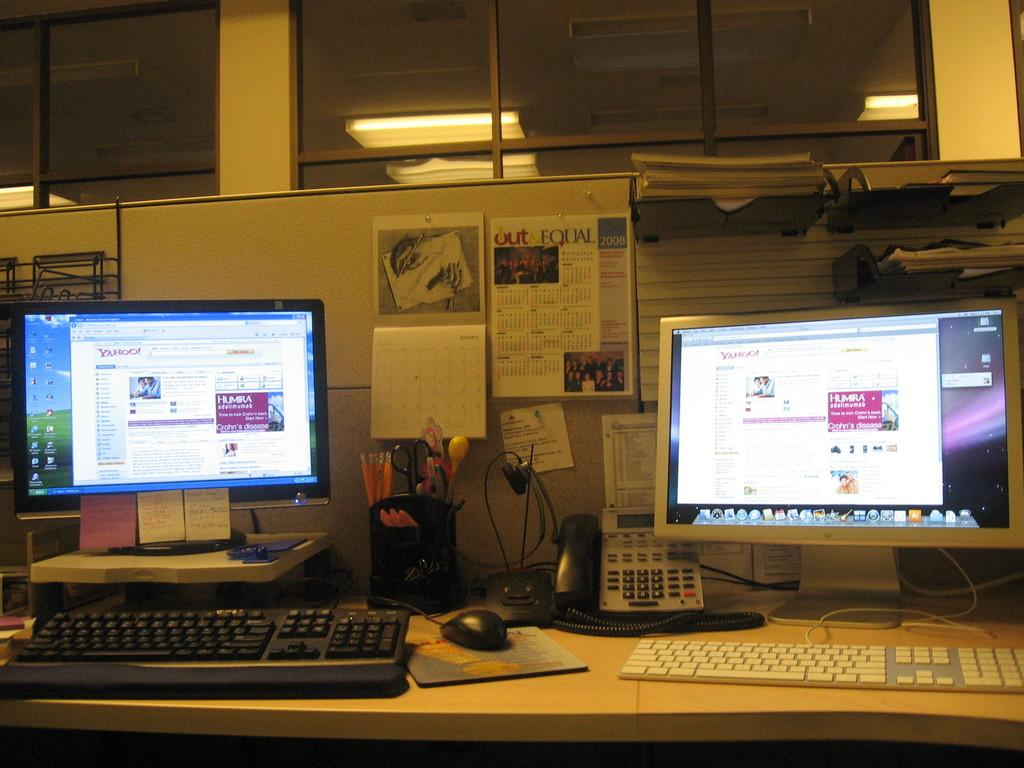<image>
Offer a succinct explanation of the picture presented. An office work desk contains two computers and a 2008 calendar. 